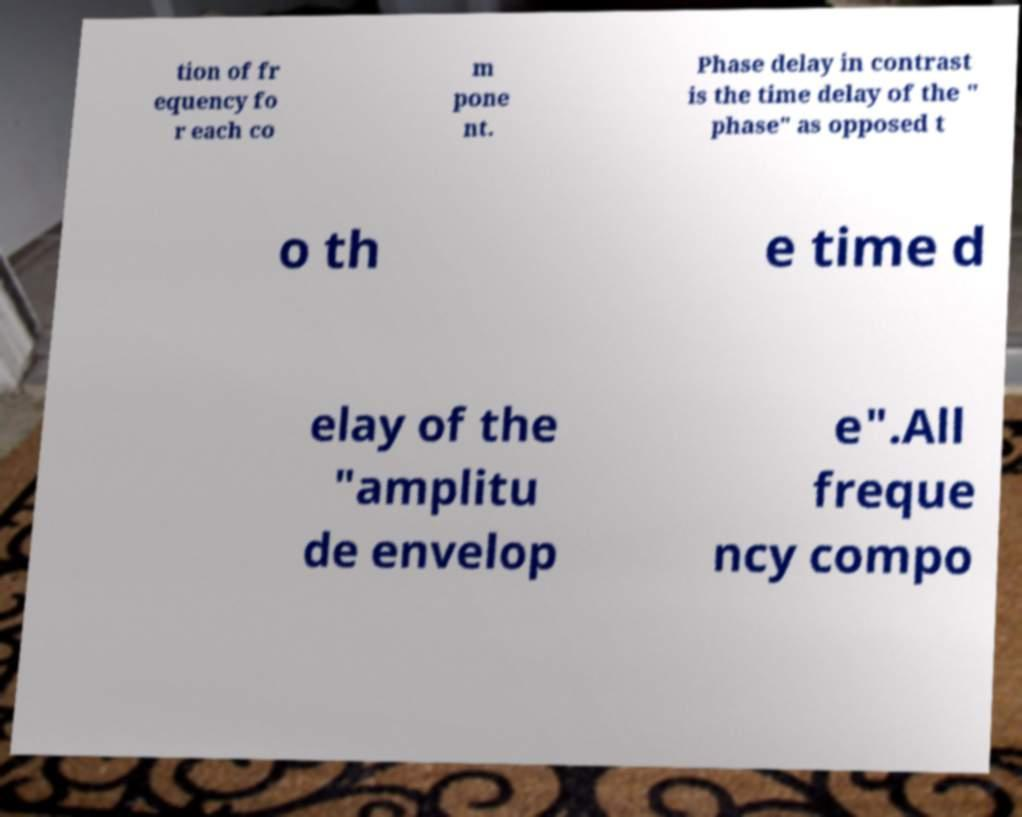Please identify and transcribe the text found in this image. tion of fr equency fo r each co m pone nt. Phase delay in contrast is the time delay of the " phase" as opposed t o th e time d elay of the "amplitu de envelop e".All freque ncy compo 